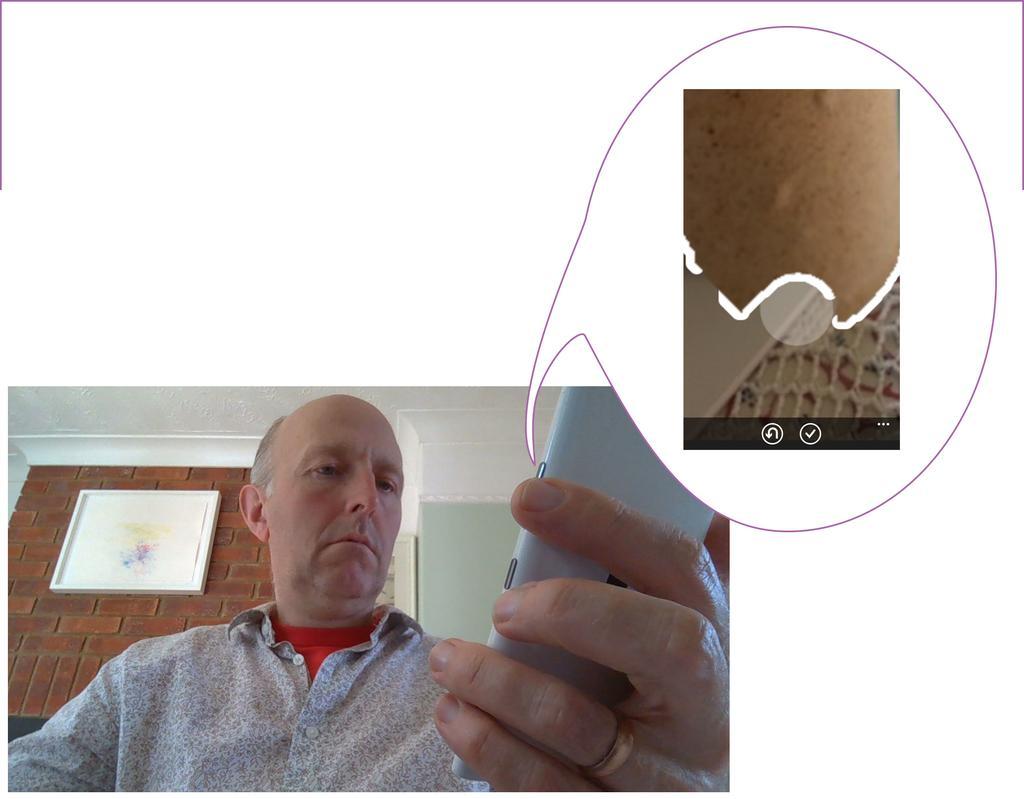How would you summarize this image in a sentence or two? In this edited image there is a person at the bottom of the image. He is holding a mobile in his hand. Behind him there is a red brick wall having a frame attached to it. Right side there is a screenshot of a screen. Background is in white color. 